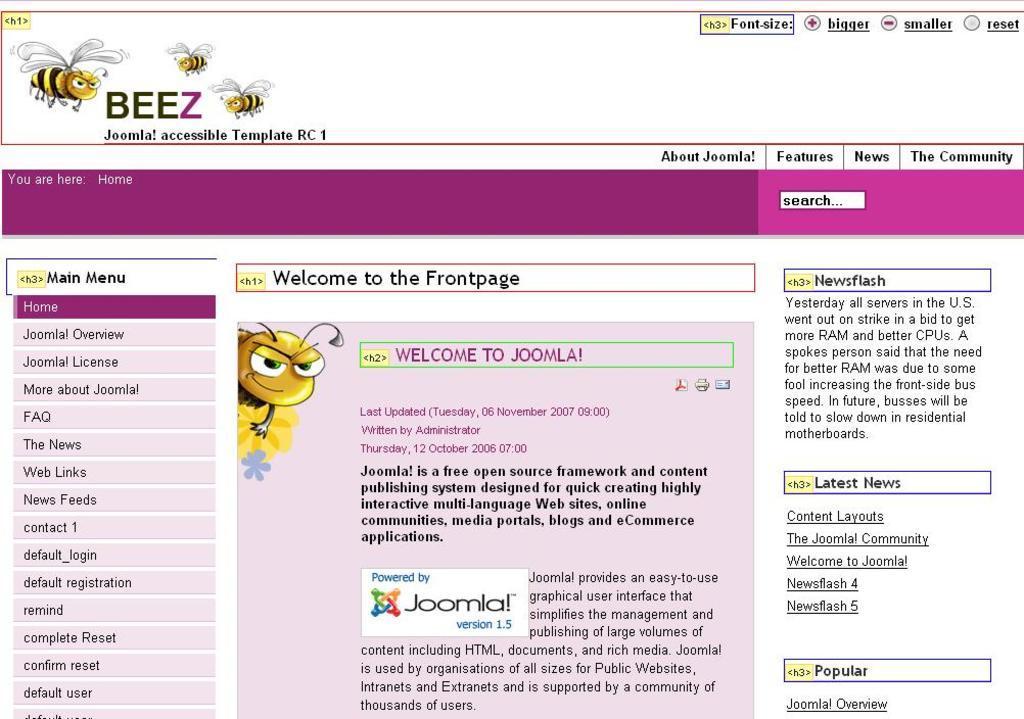In one or two sentences, can you explain what this image depicts? In this picture there is a screen shot of the computer screen. In the front there is a cartoon type honey bee and some matter written in the middle. 